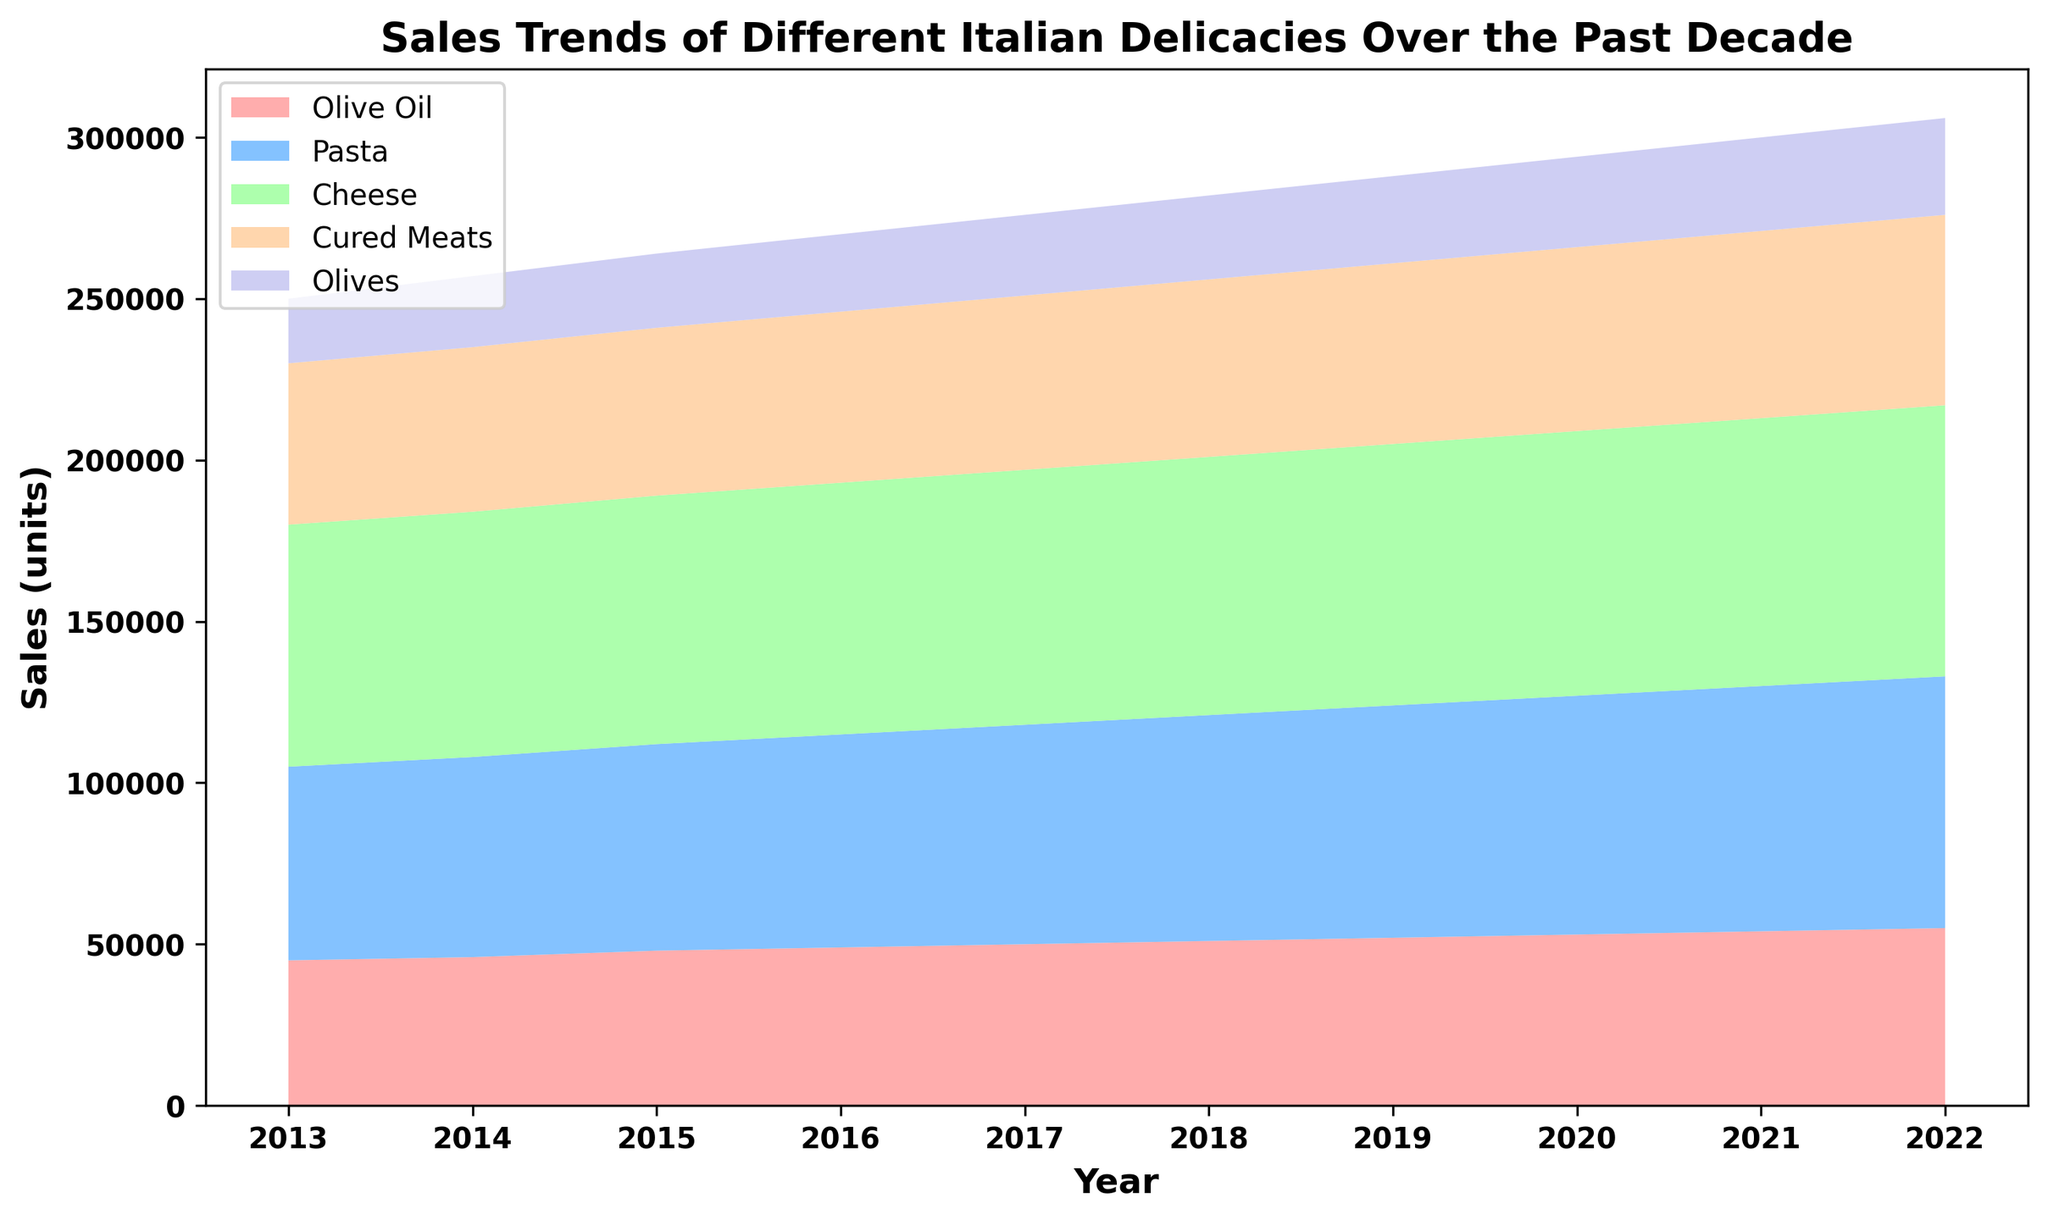What's the trend of Olive Oil sales from 2013 to 2022? Observe the "Olive Oil" area in the chart, which starts at the bottom in a reddish color. Note its increase from the left (2013) to the right (2022). The area gradually rises each year, indicating a steady growth in sales.
Answer: Steady increase Which delicacy had the highest sales in 2022? Look at the height of the areas stacked for each delicacy in 2022. The topmost segment represents Cheese, which is the highest, followed by Pasta, and others.
Answer: Cheese Between Pasta and Cheese, which had a larger increase in sales from 2016 to 2022? Compare the height difference of the "Pasta" and "Cheese" areas from 2016 to 2022. Cheese in green has a jump from 78,000 to 84,000 (6,000), while Pasta in blue increases from 66,000 to 78,000 (12,000).
Answer: Pasta What is the combined sales of Cured Meats and Olives in 2020? Add the sales figures for Cured Meats and Olives in 2020. Cured Meats are at 57,000 and Olives are at 28,000. Sum = 57,000 + 28,000.
Answer: 85,000 Identify the year where Olive Oil sales surpassed 50,000 units. Start from the leftmost side (2013) and scan through the "Olive Oil" region to identify the year when it crosses 50,000 units. This happens in 2017.
Answer: 2017 How do the sales of Cured Meats in 2014 compare to those in 2017? Observe the Cured Meats area in 2014 and 2017. In 2014, sales are at 51,000, and in 2017, they are at 54,000.
Answer: Increased by 3,000 What is the visual color associated with the Pasta sales segment? Look at the middle segment in the chart correlating to Pasta sales. It is represented in a light blue color.
Answer: Light blue Which delicacy had the least growth over the decade? Analyze the height difference from left (2013) to right (2022) for each delicacy. Olives, identified by the topmost purple region, have the least increment from 20,000 to 30,000.
Answer: Olives Calculate the average sales of Cheese from 2013 to 2022. Sum the Cheese sales from all years: 75,000 + 76,000 + 77,000 + 78,000 + 79,000 + 80,000 + 81,000 + 82,000 + 83,000 + 84,000 = 795,000. Divide by 10 years.
Answer: 79,500 